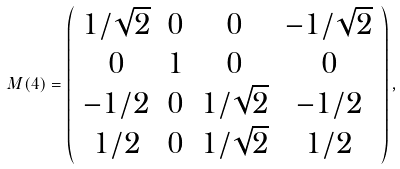Convert formula to latex. <formula><loc_0><loc_0><loc_500><loc_500>M ( 4 ) = \left ( \begin{array} { c c c c } 1 / \sqrt { 2 } & 0 & 0 & - 1 / \sqrt { 2 } \\ 0 & 1 & 0 & 0 \\ - 1 / 2 & 0 & 1 / \sqrt { 2 } & - 1 / 2 \\ 1 / 2 & 0 & 1 / \sqrt { 2 } & 1 / 2 \end{array} \right ) ,</formula> 